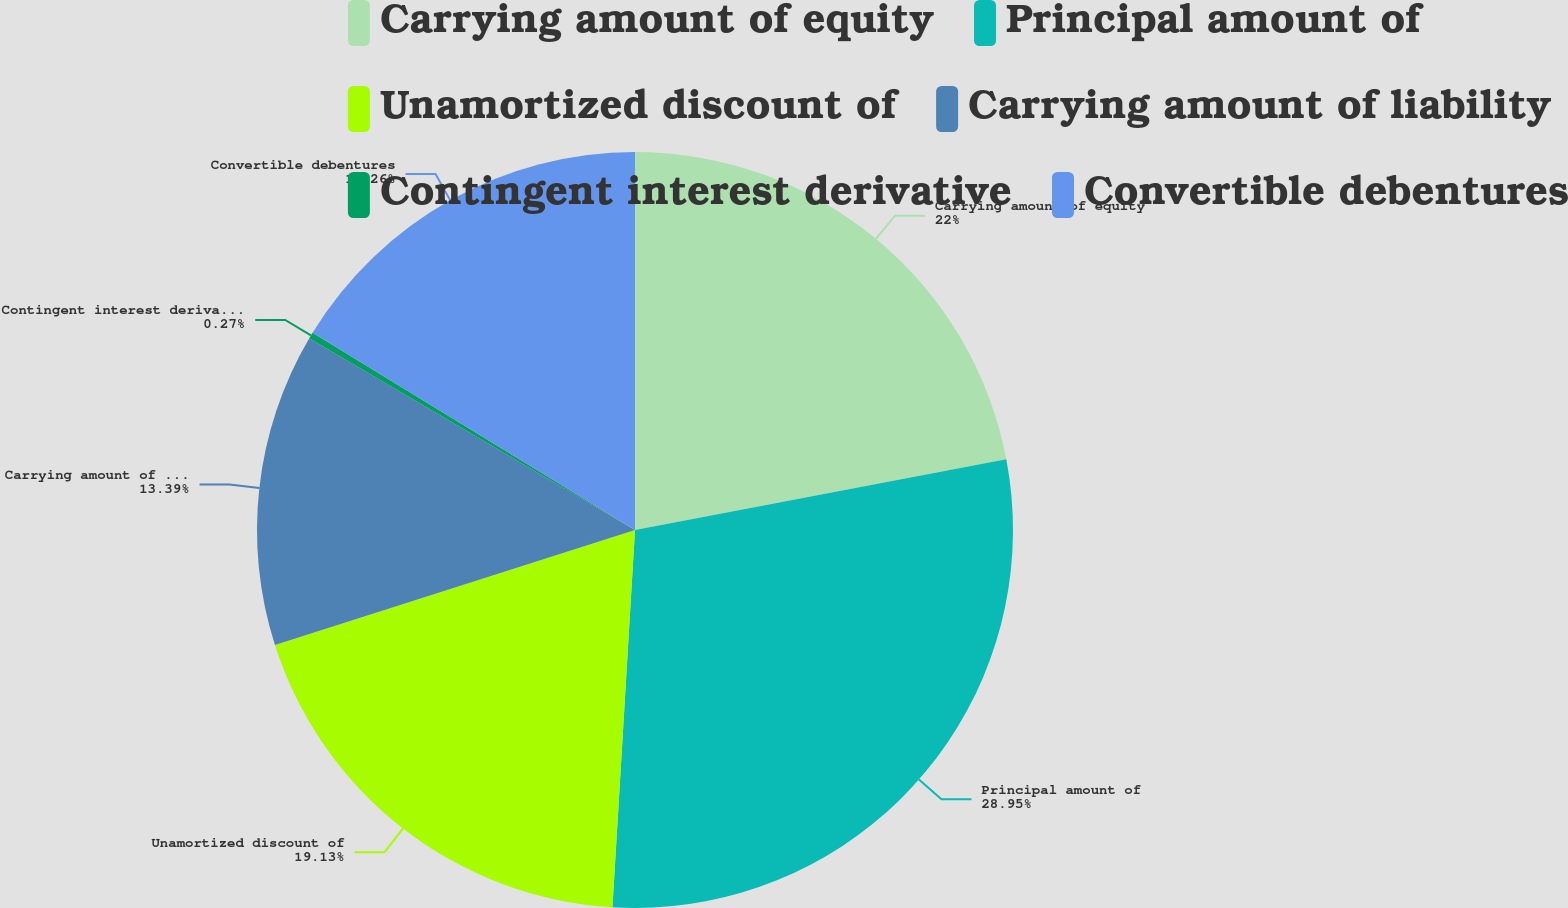Convert chart. <chart><loc_0><loc_0><loc_500><loc_500><pie_chart><fcel>Carrying amount of equity<fcel>Principal amount of<fcel>Unamortized discount of<fcel>Carrying amount of liability<fcel>Contingent interest derivative<fcel>Convertible debentures<nl><fcel>22.0%<fcel>28.95%<fcel>19.13%<fcel>13.39%<fcel>0.27%<fcel>16.26%<nl></chart> 